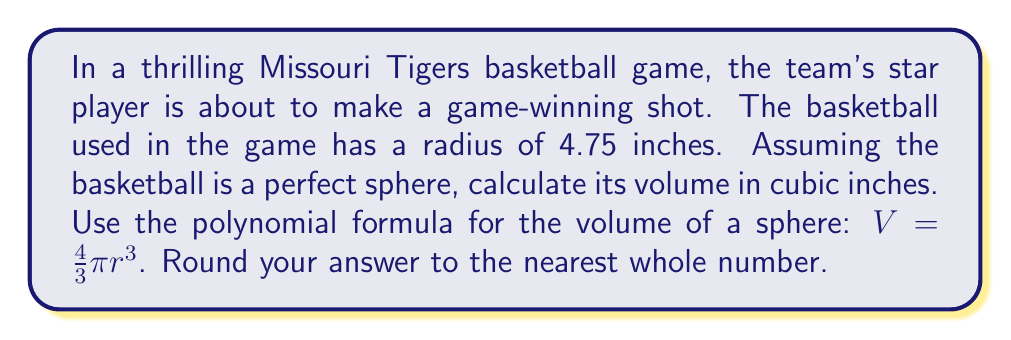Give your solution to this math problem. Let's solve this step-by-step:

1) We are given that the radius of the basketball is 4.75 inches.

2) The formula for the volume of a sphere is:

   $$V = \frac{4}{3}\pi r^3$$

3) Let's substitute our known value:

   $$V = \frac{4}{3}\pi (4.75)^3$$

4) First, let's calculate $r^3$:
   
   $$(4.75)^3 = 4.75 \times 4.75 \times 4.75 = 107.171875$$

5) Now our equation looks like this:

   $$V = \frac{4}{3}\pi (107.171875)$$

6) Multiply by $\frac{4}{3}$:

   $$V = 4\pi (35.7239583)$$

7) Multiply by $\pi$ (we'll use 3.14159 for $\pi$):

   $$V = 4 \times 3.14159 \times 35.7239583 = 448.9206$$

8) Rounding to the nearest whole number:

   $$V \approx 449$$

Therefore, the volume of the basketball is approximately 449 cubic inches.
Answer: 449 cubic inches 